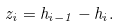<formula> <loc_0><loc_0><loc_500><loc_500>z _ { i } = h _ { i - 1 } - h _ { i } .</formula> 